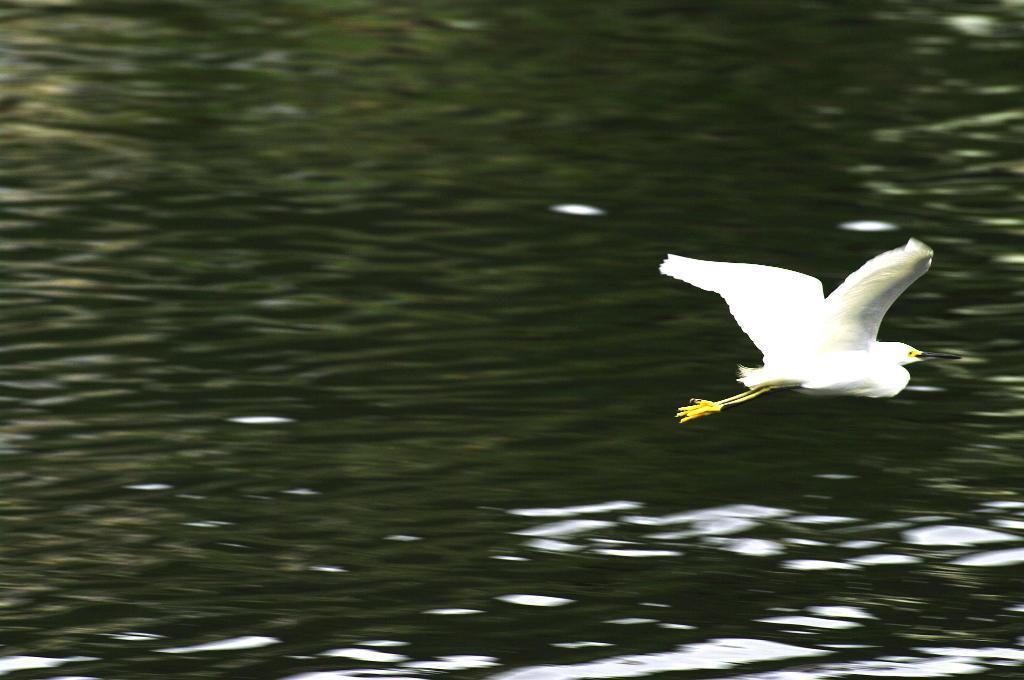Please provide a concise description of this image. In this image I can see a bird flying in the air. The bird is in white and yellow color. In the background I can see the water. 